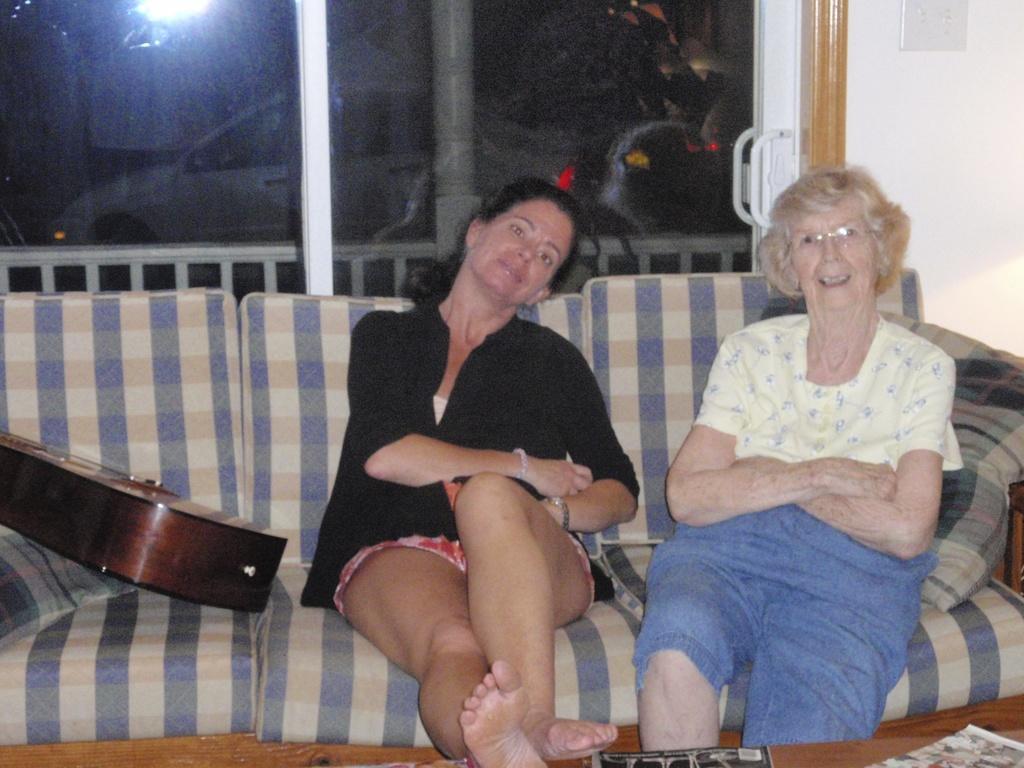In one or two sentences, can you explain what this image depicts? In the picture I can see two women sitting in a sofa and there is a guitar and a pillow in the left corner and there is a glass door in the background. 